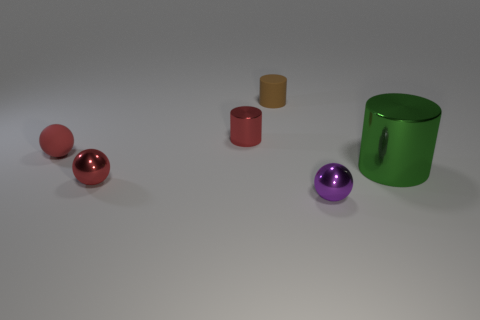What size is the matte object that is the same shape as the big green shiny object? The matte object that shares the same cylindrical shape as the big green shiny object seems to be medium-sized when compared to the other objects in the image. 